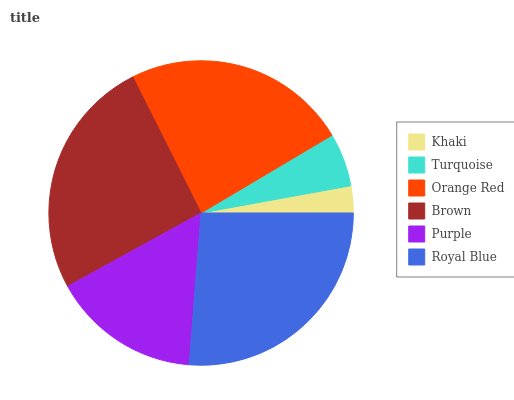Is Khaki the minimum?
Answer yes or no. Yes. Is Royal Blue the maximum?
Answer yes or no. Yes. Is Turquoise the minimum?
Answer yes or no. No. Is Turquoise the maximum?
Answer yes or no. No. Is Turquoise greater than Khaki?
Answer yes or no. Yes. Is Khaki less than Turquoise?
Answer yes or no. Yes. Is Khaki greater than Turquoise?
Answer yes or no. No. Is Turquoise less than Khaki?
Answer yes or no. No. Is Orange Red the high median?
Answer yes or no. Yes. Is Purple the low median?
Answer yes or no. Yes. Is Royal Blue the high median?
Answer yes or no. No. Is Orange Red the low median?
Answer yes or no. No. 